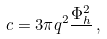Convert formula to latex. <formula><loc_0><loc_0><loc_500><loc_500>c = 3 \pi q ^ { 2 } \frac { \Phi _ { h } ^ { 2 } } { } \, ,</formula> 